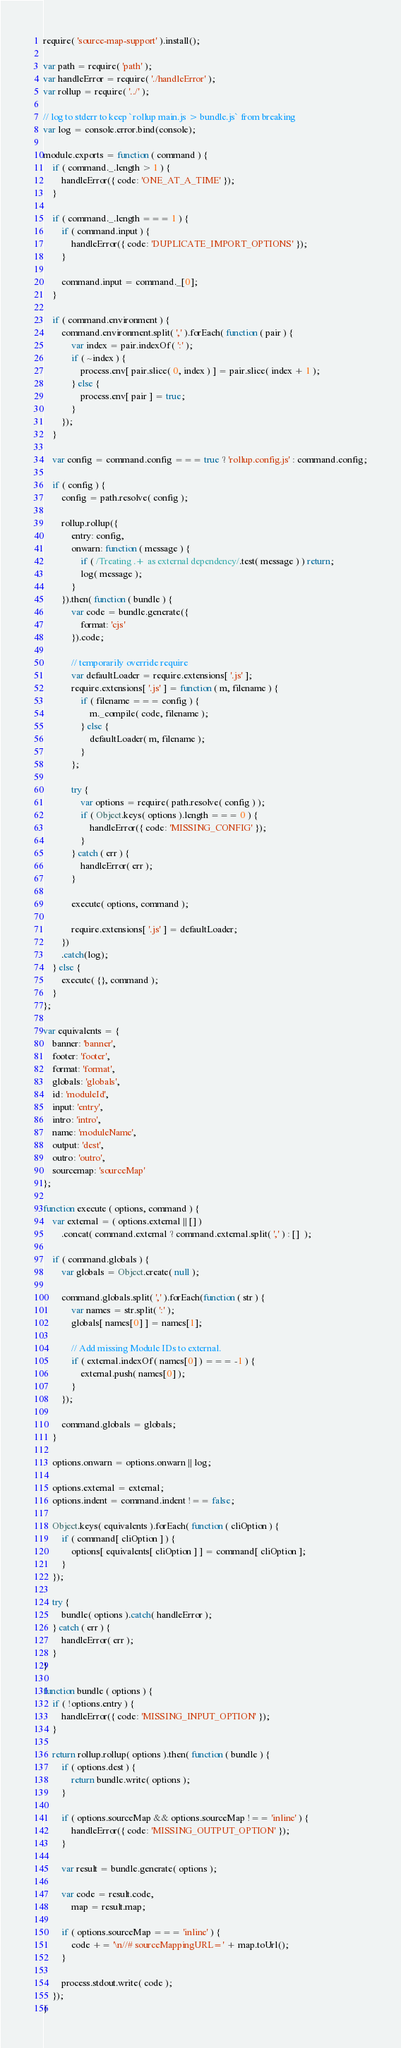<code> <loc_0><loc_0><loc_500><loc_500><_JavaScript_>require( 'source-map-support' ).install();

var path = require( 'path' );
var handleError = require( './handleError' );
var rollup = require( '../' );

// log to stderr to keep `rollup main.js > bundle.js` from breaking
var log = console.error.bind(console);

module.exports = function ( command ) {
	if ( command._.length > 1 ) {
		handleError({ code: 'ONE_AT_A_TIME' });
	}

	if ( command._.length === 1 ) {
		if ( command.input ) {
			handleError({ code: 'DUPLICATE_IMPORT_OPTIONS' });
		}

		command.input = command._[0];
	}

	if ( command.environment ) {
		command.environment.split( ',' ).forEach( function ( pair ) {
			var index = pair.indexOf( ':' );
			if ( ~index ) {
				process.env[ pair.slice( 0, index ) ] = pair.slice( index + 1 );
			} else {
				process.env[ pair ] = true;
			}
		});
	}

	var config = command.config === true ? 'rollup.config.js' : command.config;

	if ( config ) {
		config = path.resolve( config );

		rollup.rollup({
			entry: config,
			onwarn: function ( message ) {
				if ( /Treating .+ as external dependency/.test( message ) ) return;
				log( message );
			}
		}).then( function ( bundle ) {
			var code = bundle.generate({
				format: 'cjs'
			}).code;

			// temporarily override require
			var defaultLoader = require.extensions[ '.js' ];
			require.extensions[ '.js' ] = function ( m, filename ) {
				if ( filename === config ) {
					m._compile( code, filename );
				} else {
					defaultLoader( m, filename );
				}
			};

			try {
				var options = require( path.resolve( config ) );
				if ( Object.keys( options ).length === 0 ) {
					handleError({ code: 'MISSING_CONFIG' });
				}
			} catch ( err ) {
				handleError( err );
			}

			execute( options, command );

			require.extensions[ '.js' ] = defaultLoader;
		})
		.catch(log);
	} else {
		execute( {}, command );
	}
};

var equivalents = {
	banner: 'banner',
	footer: 'footer',
	format: 'format',
	globals: 'globals',
	id: 'moduleId',
	input: 'entry',
	intro: 'intro',
	name: 'moduleName',
	output: 'dest',
	outro: 'outro',
	sourcemap: 'sourceMap'
};

function execute ( options, command ) {
	var external = ( options.external || [] )
		.concat( command.external ? command.external.split( ',' ) : []  );

	if ( command.globals ) {
		var globals = Object.create( null );

		command.globals.split( ',' ).forEach(function ( str ) {
			var names = str.split( ':' );
			globals[ names[0] ] = names[1];

			// Add missing Module IDs to external.
			if ( external.indexOf( names[0] ) === -1 ) {
				external.push( names[0] );
			}
		});

		command.globals = globals;
	}

	options.onwarn = options.onwarn || log;

	options.external = external;
	options.indent = command.indent !== false;

	Object.keys( equivalents ).forEach( function ( cliOption ) {
		if ( command[ cliOption ] ) {
			options[ equivalents[ cliOption ] ] = command[ cliOption ];
		}
	});

	try {
		bundle( options ).catch( handleError );
	} catch ( err ) {
		handleError( err );
	}
}

function bundle ( options ) {
	if ( !options.entry ) {
		handleError({ code: 'MISSING_INPUT_OPTION' });
	}

	return rollup.rollup( options ).then( function ( bundle ) {
		if ( options.dest ) {
			return bundle.write( options );
		}

		if ( options.sourceMap && options.sourceMap !== 'inline' ) {
			handleError({ code: 'MISSING_OUTPUT_OPTION' });
		}

		var result = bundle.generate( options );

		var code = result.code,
			map = result.map;

		if ( options.sourceMap === 'inline' ) {
			code += '\n//# sourceMappingURL=' + map.toUrl();
		}

		process.stdout.write( code );
	});
}
</code> 